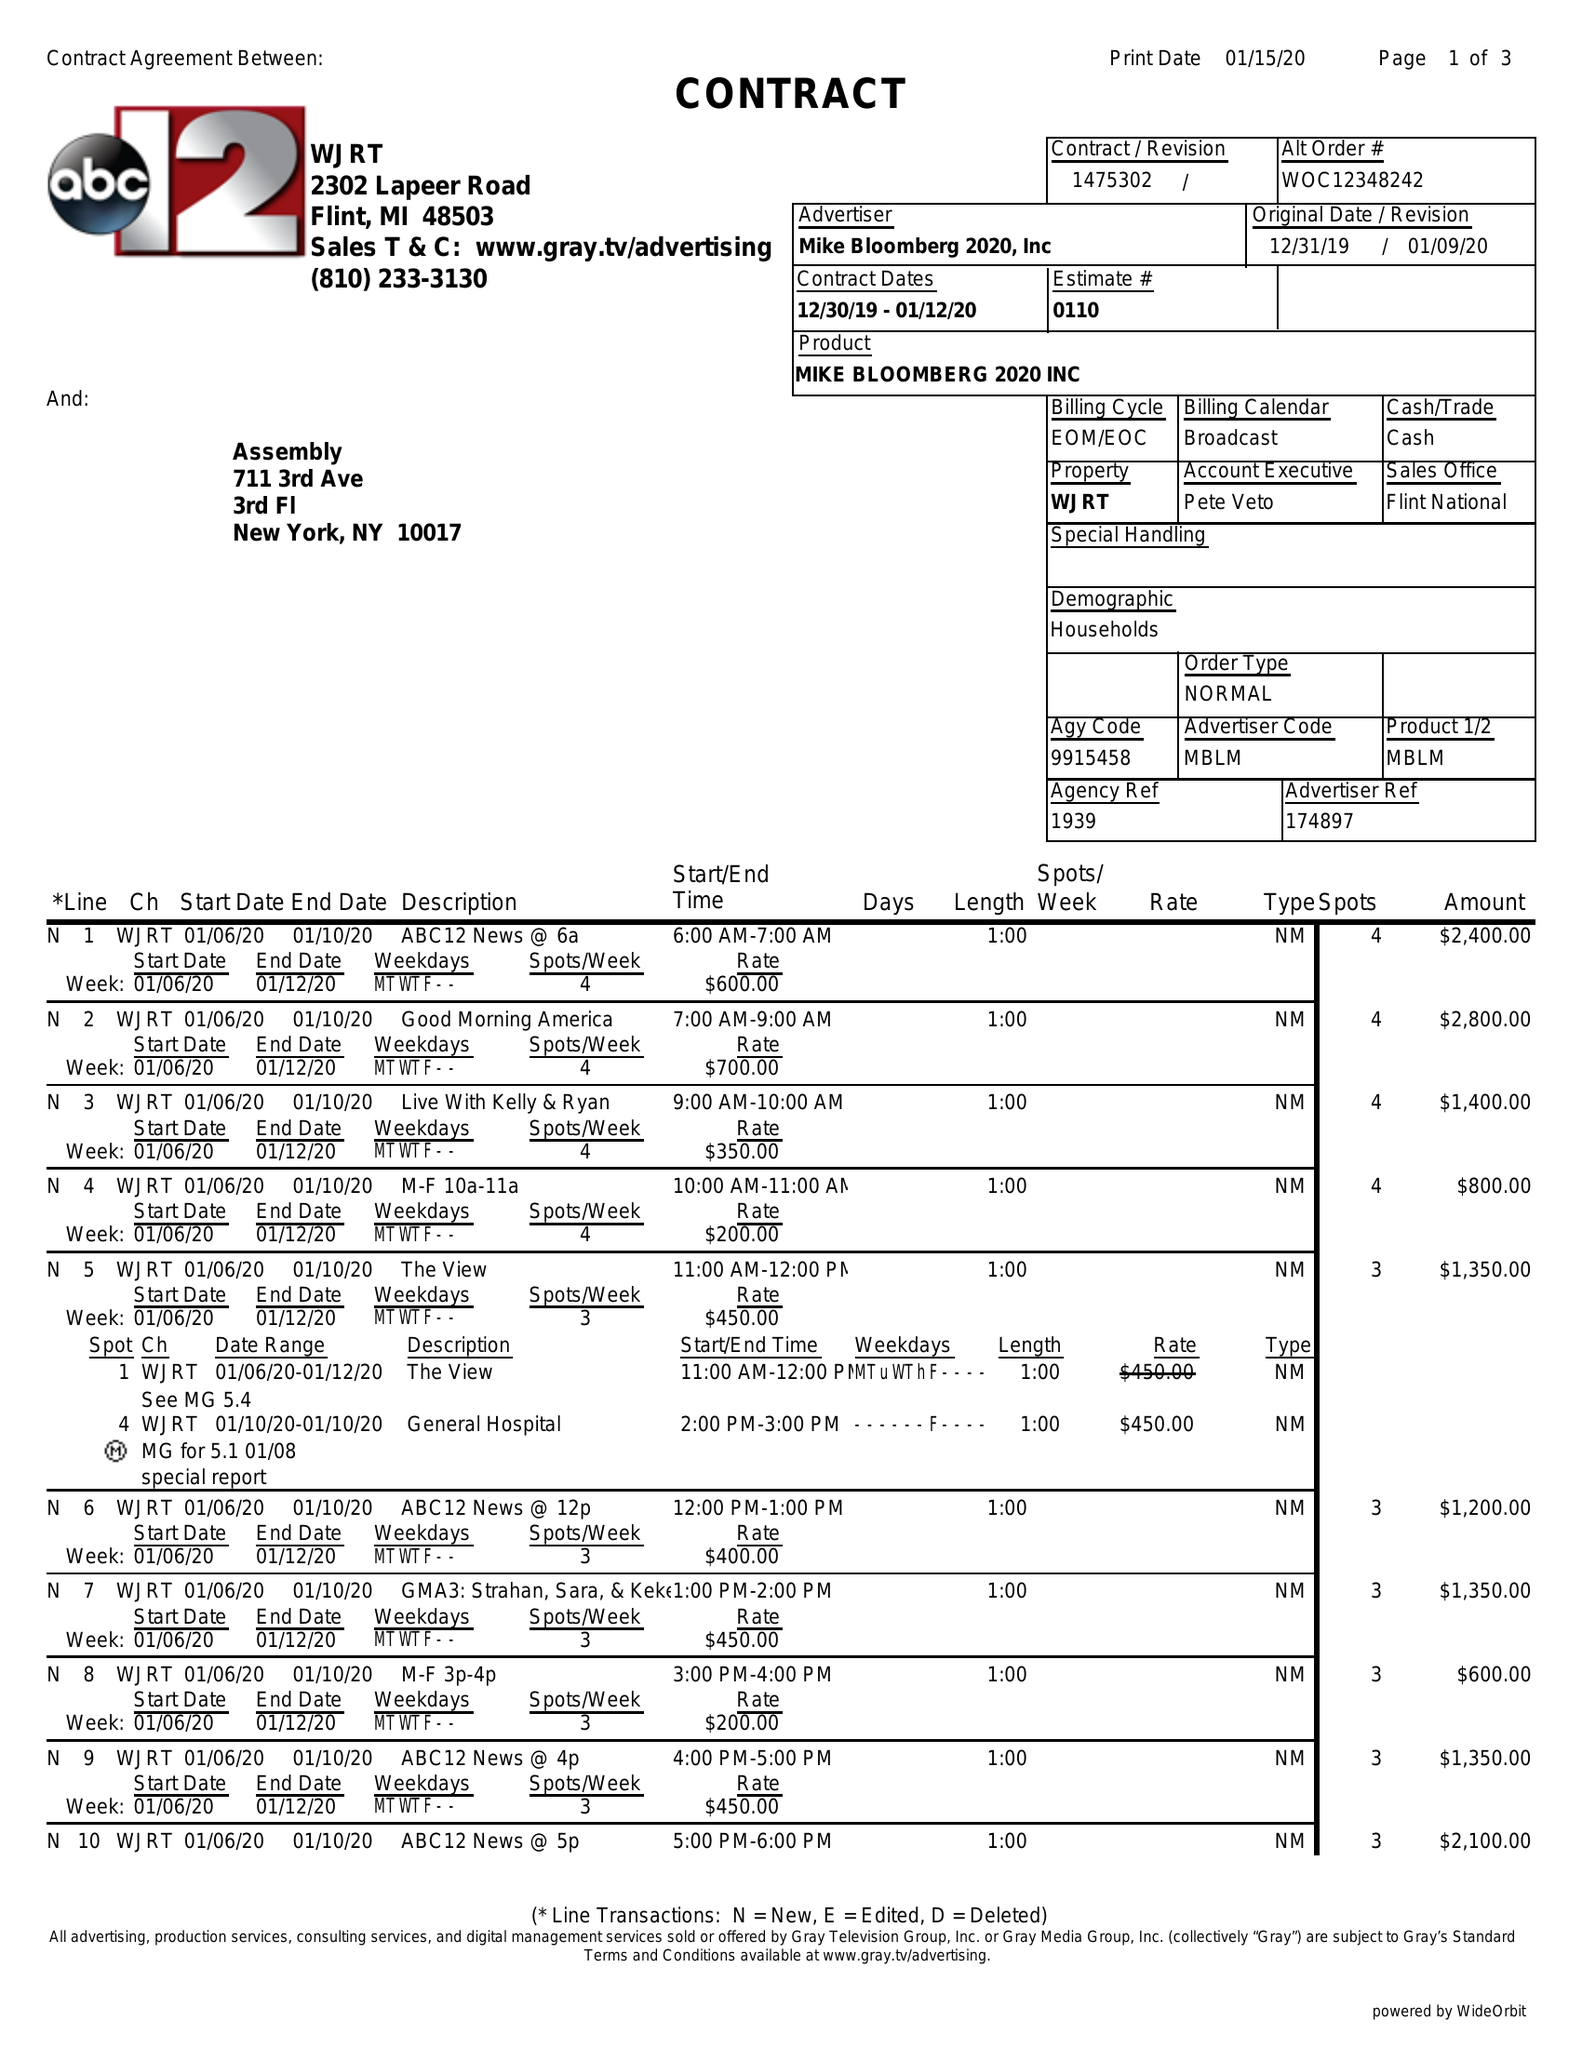What is the value for the contract_num?
Answer the question using a single word or phrase. 1475302 